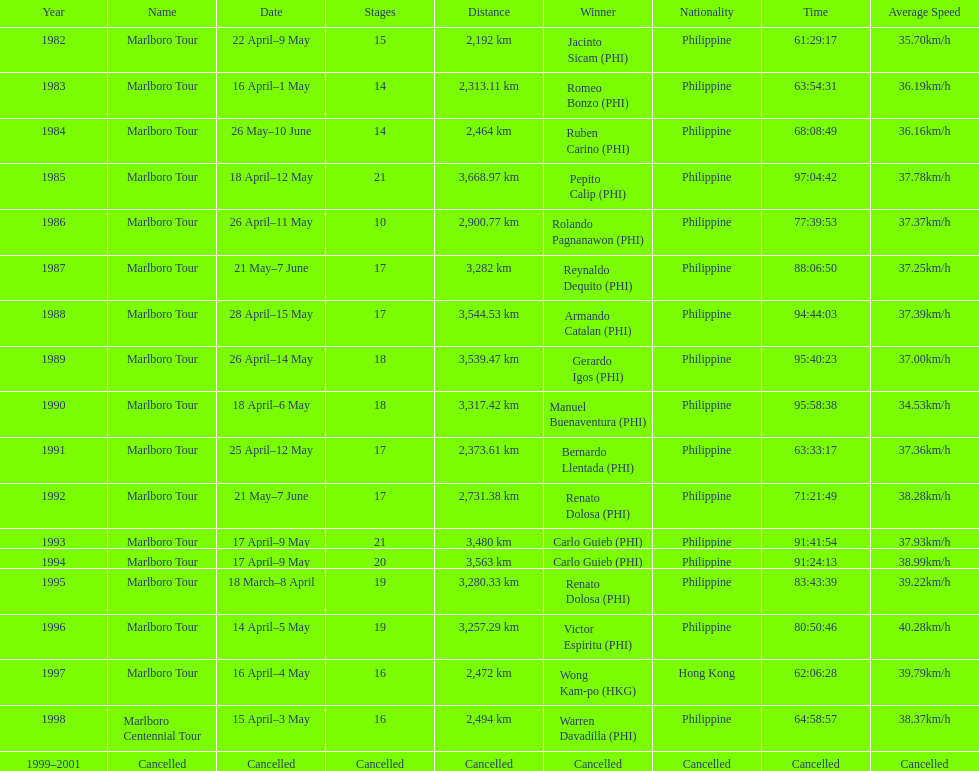Who was the only winner to have their time below 61:45:00? Jacinto Sicam. 